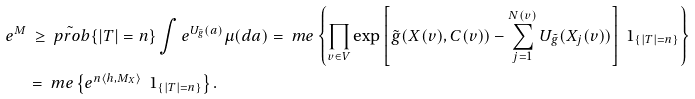Convert formula to latex. <formula><loc_0><loc_0><loc_500><loc_500>e ^ { M } & \, \geq \tilde { \ p r o b } \{ | T | = n \} \int e ^ { U _ { \tilde { g } } ( a ) } \mu ( d a ) = \ m e \left \{ \prod _ { v \in V } \exp \left [ \tilde { g } ( X ( v ) , C ( v ) ) - \sum _ { j = 1 } ^ { N ( v ) } U _ { \tilde { g } } ( X _ { j } ( v ) ) \right ] \ 1 _ { \{ | T | = n \} } \right \} \\ & = \ m e \left \{ e ^ { n \langle h , M _ { X } \rangle } \, \ 1 _ { \{ | T | = n \} } \right \} .</formula> 